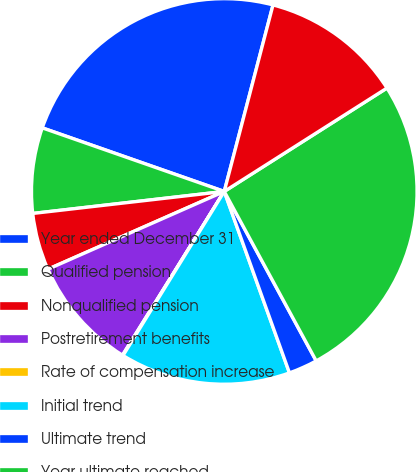Convert chart to OTSL. <chart><loc_0><loc_0><loc_500><loc_500><pie_chart><fcel>Year ended December 31<fcel>Qualified pension<fcel>Nonqualified pension<fcel>Postretirement benefits<fcel>Rate of compensation increase<fcel>Initial trend<fcel>Ultimate trend<fcel>Year ultimate reached<fcel>Expected long-term return on<nl><fcel>23.72%<fcel>7.17%<fcel>4.79%<fcel>9.54%<fcel>0.05%<fcel>14.29%<fcel>2.42%<fcel>26.1%<fcel>11.92%<nl></chart> 